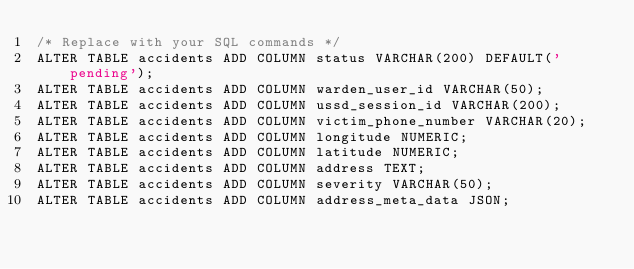Convert code to text. <code><loc_0><loc_0><loc_500><loc_500><_SQL_>/* Replace with your SQL commands */
ALTER TABLE accidents ADD COLUMN status VARCHAR(200) DEFAULT('pending');
ALTER TABLE accidents ADD COLUMN warden_user_id VARCHAR(50);
ALTER TABLE accidents ADD COLUMN ussd_session_id VARCHAR(200);
ALTER TABLE accidents ADD COLUMN victim_phone_number VARCHAR(20);
ALTER TABLE accidents ADD COLUMN longitude NUMERIC;
ALTER TABLE accidents ADD COLUMN latitude NUMERIC;
ALTER TABLE accidents ADD COLUMN address TEXT;
ALTER TABLE accidents ADD COLUMN severity VARCHAR(50);
ALTER TABLE accidents ADD COLUMN address_meta_data JSON;




</code> 